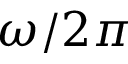<formula> <loc_0><loc_0><loc_500><loc_500>\omega / 2 \pi</formula> 